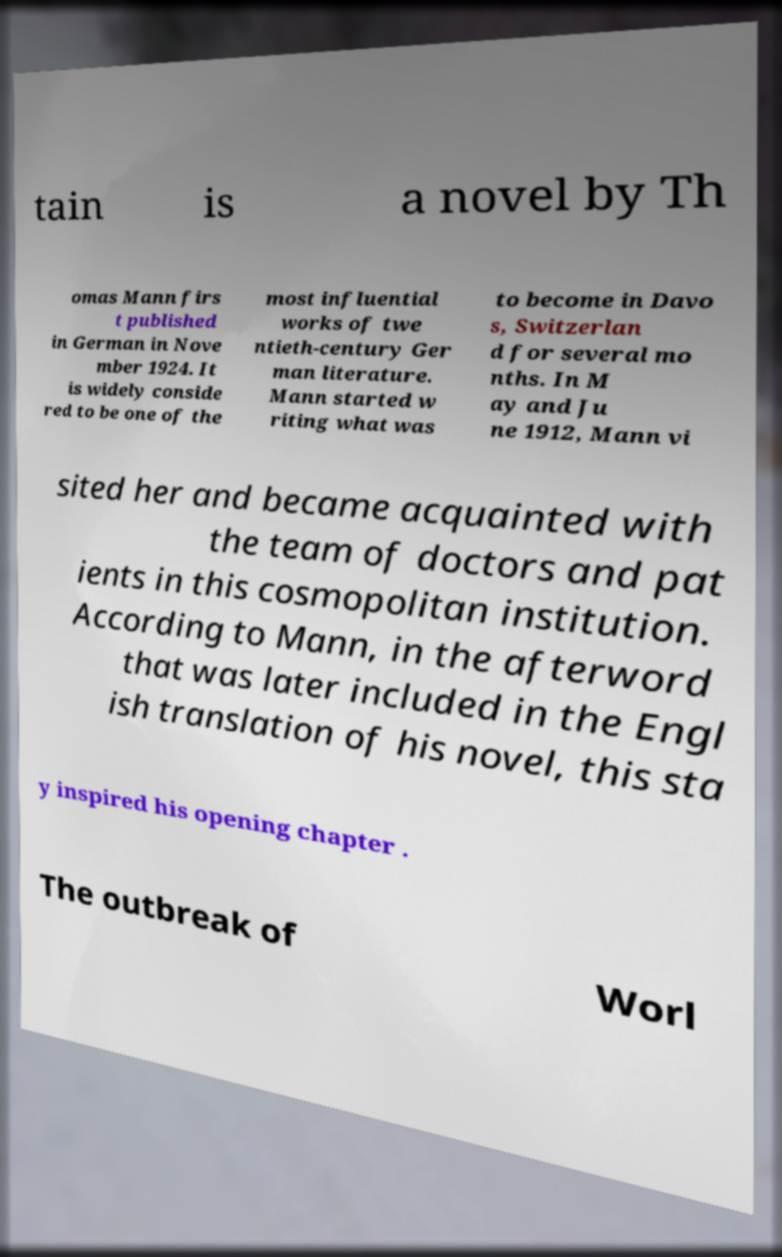Please identify and transcribe the text found in this image. tain is a novel by Th omas Mann firs t published in German in Nove mber 1924. It is widely conside red to be one of the most influential works of twe ntieth-century Ger man literature. Mann started w riting what was to become in Davo s, Switzerlan d for several mo nths. In M ay and Ju ne 1912, Mann vi sited her and became acquainted with the team of doctors and pat ients in this cosmopolitan institution. According to Mann, in the afterword that was later included in the Engl ish translation of his novel, this sta y inspired his opening chapter . The outbreak of Worl 